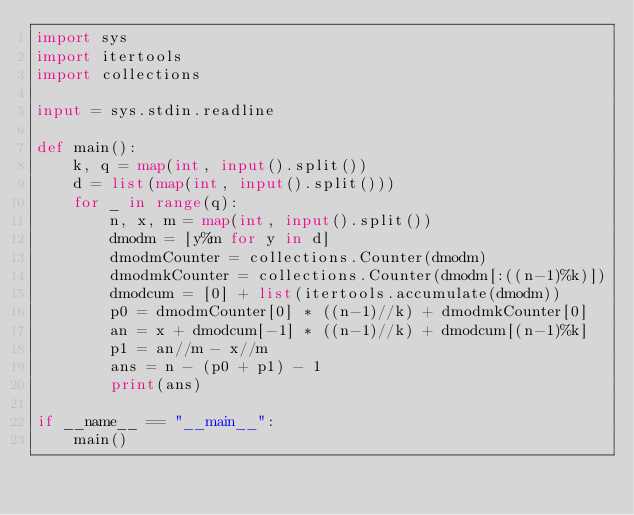Convert code to text. <code><loc_0><loc_0><loc_500><loc_500><_Python_>import sys
import itertools
import collections

input = sys.stdin.readline

def main():
    k, q = map(int, input().split())
    d = list(map(int, input().split()))
    for _ in range(q):
        n, x, m = map(int, input().split())
        dmodm = [y%m for y in d]
        dmodmCounter = collections.Counter(dmodm)
        dmodmkCounter = collections.Counter(dmodm[:((n-1)%k)])
        dmodcum = [0] + list(itertools.accumulate(dmodm))
        p0 = dmodmCounter[0] * ((n-1)//k) + dmodmkCounter[0]
        an = x + dmodcum[-1] * ((n-1)//k) + dmodcum[(n-1)%k]
        p1 = an//m - x//m
        ans = n - (p0 + p1) - 1
        print(ans)

if __name__ == "__main__":
    main()
</code> 